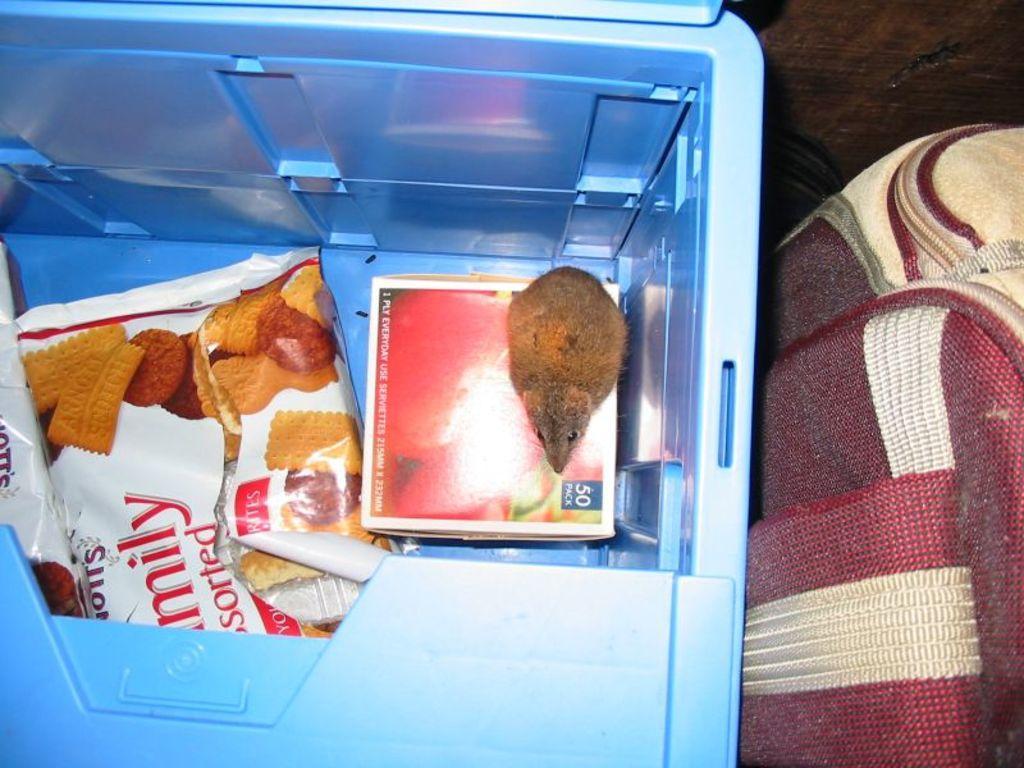In one or two sentences, can you explain what this image depicts? On the left of this picture we can see an object which seems to be a refrigerator containing the packets of food items and a box on which we can see a rat. On the right there is an object which seems to be the bag. 